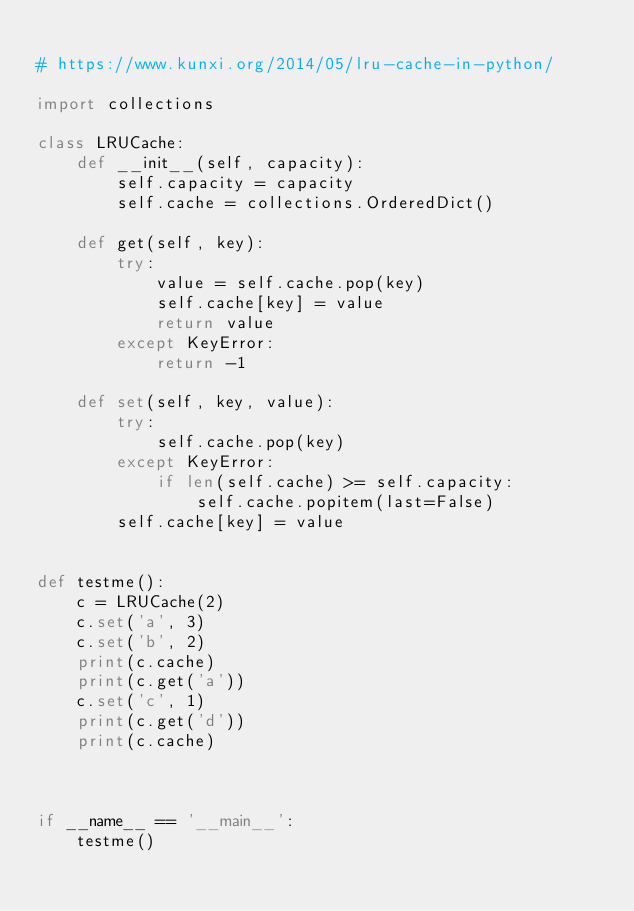Convert code to text. <code><loc_0><loc_0><loc_500><loc_500><_Python_>
# https://www.kunxi.org/2014/05/lru-cache-in-python/

import collections

class LRUCache:
    def __init__(self, capacity):
        self.capacity = capacity
        self.cache = collections.OrderedDict()

    def get(self, key):
        try:
            value = self.cache.pop(key)
            self.cache[key] = value
            return value
        except KeyError:
            return -1

    def set(self, key, value):
        try:
            self.cache.pop(key)
        except KeyError:
            if len(self.cache) >= self.capacity:
                self.cache.popitem(last=False)
        self.cache[key] = value


def testme():
    c = LRUCache(2)
    c.set('a', 3)
    c.set('b', 2)
    print(c.cache)
    print(c.get('a'))
    c.set('c', 1)
    print(c.get('d'))
    print(c.cache)



if __name__ == '__main__':
    testme()

</code> 